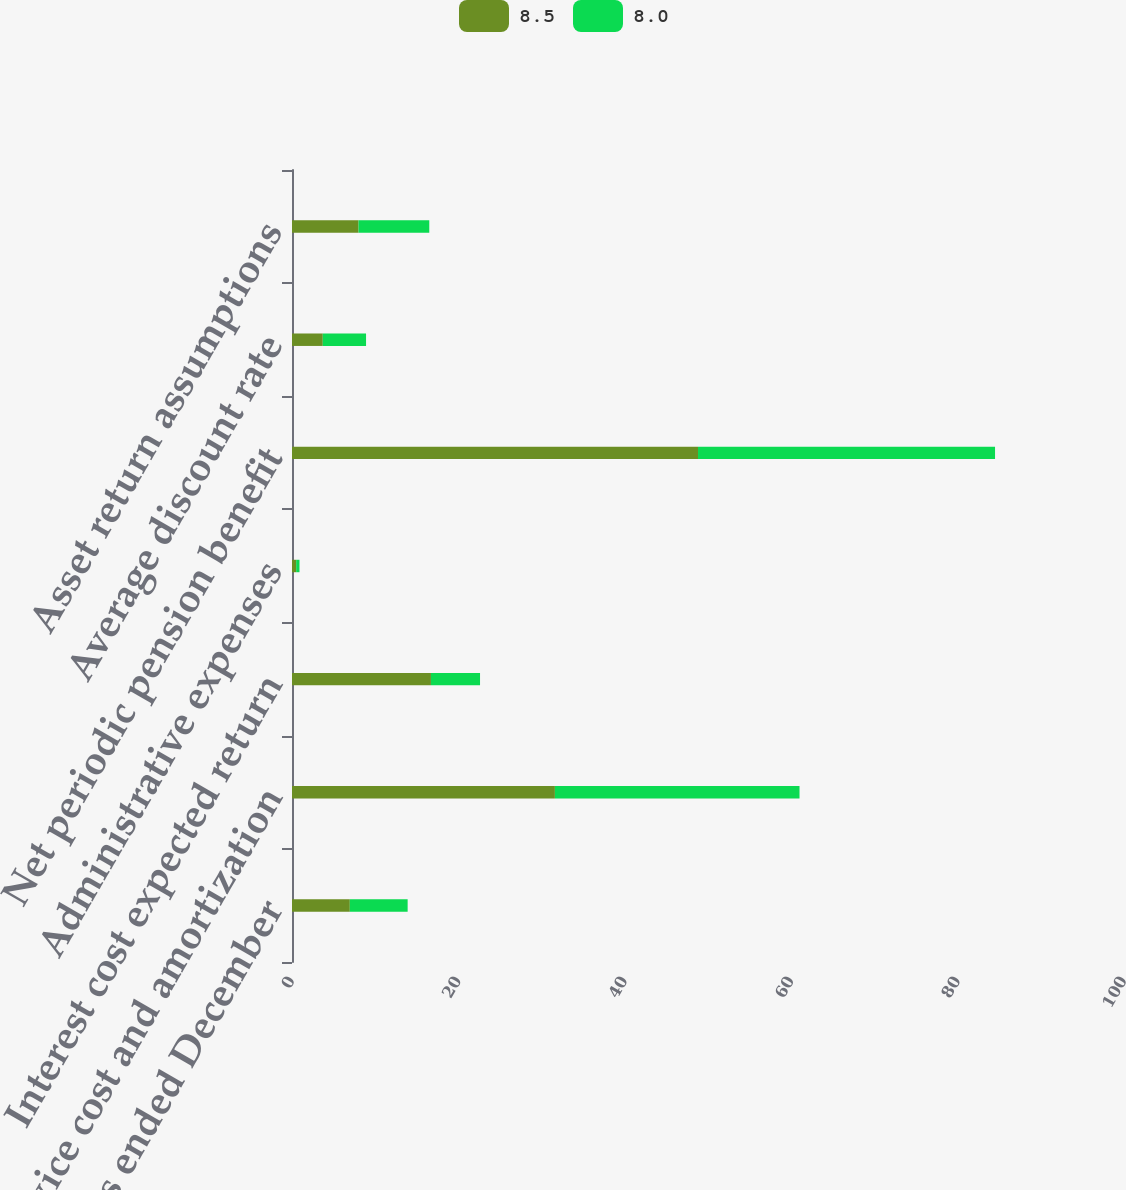Convert chart. <chart><loc_0><loc_0><loc_500><loc_500><stacked_bar_chart><ecel><fcel>For the years ended December<fcel>Service cost and amortization<fcel>Interest cost expected return<fcel>Administrative expenses<fcel>Net periodic pension benefit<fcel>Average discount rate<fcel>Asset return assumptions<nl><fcel>8.5<fcel>6.95<fcel>31.6<fcel>16.7<fcel>0.5<fcel>48.8<fcel>3.7<fcel>8<nl><fcel>8<fcel>6.95<fcel>29.4<fcel>5.9<fcel>0.4<fcel>35.7<fcel>5.2<fcel>8.5<nl></chart> 